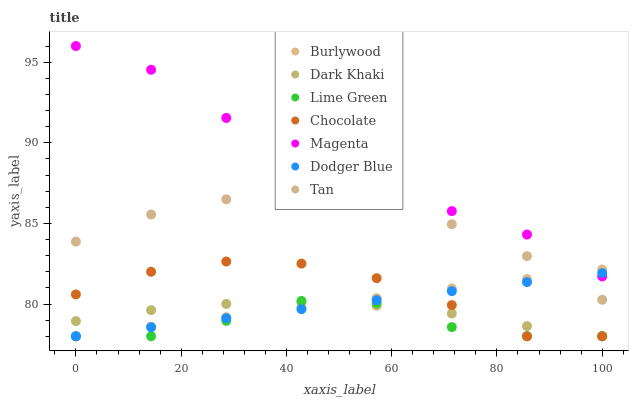Does Lime Green have the minimum area under the curve?
Answer yes or no. Yes. Does Magenta have the maximum area under the curve?
Answer yes or no. Yes. Does Chocolate have the minimum area under the curve?
Answer yes or no. No. Does Chocolate have the maximum area under the curve?
Answer yes or no. No. Is Burlywood the smoothest?
Answer yes or no. Yes. Is Lime Green the roughest?
Answer yes or no. Yes. Is Chocolate the smoothest?
Answer yes or no. No. Is Chocolate the roughest?
Answer yes or no. No. Does Burlywood have the lowest value?
Answer yes or no. Yes. Does Magenta have the lowest value?
Answer yes or no. No. Does Magenta have the highest value?
Answer yes or no. Yes. Does Chocolate have the highest value?
Answer yes or no. No. Is Lime Green less than Tan?
Answer yes or no. Yes. Is Magenta greater than Chocolate?
Answer yes or no. Yes. Does Tan intersect Burlywood?
Answer yes or no. Yes. Is Tan less than Burlywood?
Answer yes or no. No. Is Tan greater than Burlywood?
Answer yes or no. No. Does Lime Green intersect Tan?
Answer yes or no. No. 